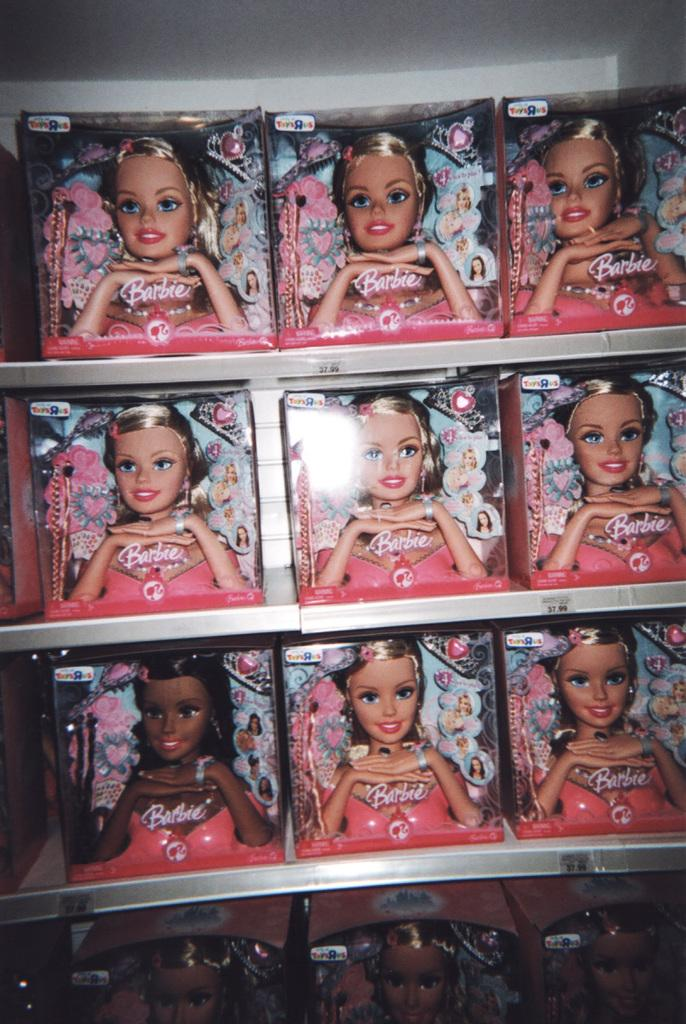What type of storage units are visible in the image? There are shelves in the image. What items are stored on the shelves? There are boxes with Barbie dolls on the shelves. What can be seen in the background of the image? There is a wall in the background of the image. Where is the hat stored in the image? There is no hat present in the image. Can you describe the cellar in the image? There is no cellar present in the image. 